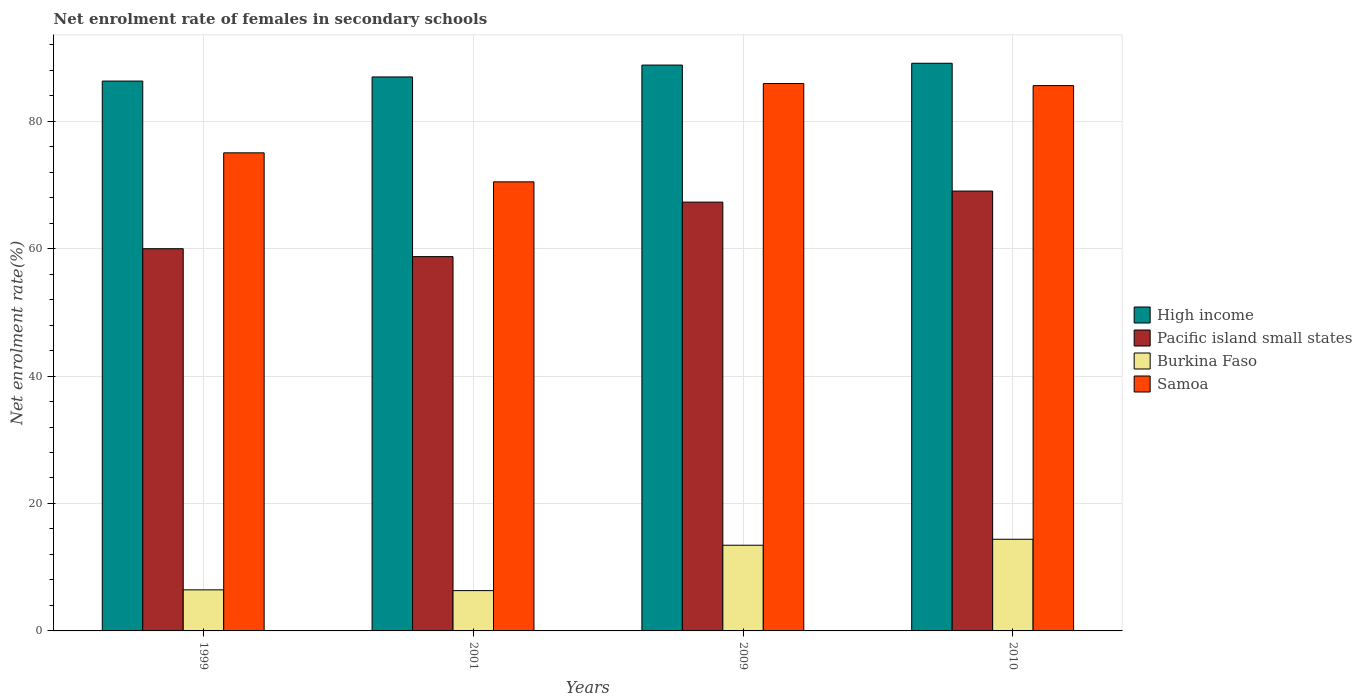How many bars are there on the 4th tick from the left?
Your answer should be compact. 4. How many bars are there on the 4th tick from the right?
Your answer should be very brief. 4. What is the label of the 3rd group of bars from the left?
Make the answer very short. 2009. What is the net enrolment rate of females in secondary schools in Samoa in 1999?
Keep it short and to the point. 75.03. Across all years, what is the maximum net enrolment rate of females in secondary schools in Samoa?
Keep it short and to the point. 85.9. Across all years, what is the minimum net enrolment rate of females in secondary schools in Burkina Faso?
Your answer should be very brief. 6.33. What is the total net enrolment rate of females in secondary schools in Samoa in the graph?
Your answer should be very brief. 316.98. What is the difference between the net enrolment rate of females in secondary schools in Burkina Faso in 1999 and that in 2010?
Offer a terse response. -7.94. What is the difference between the net enrolment rate of females in secondary schools in Samoa in 2010 and the net enrolment rate of females in secondary schools in Burkina Faso in 1999?
Your answer should be compact. 79.13. What is the average net enrolment rate of females in secondary schools in Pacific island small states per year?
Your answer should be compact. 63.76. In the year 2001, what is the difference between the net enrolment rate of females in secondary schools in Pacific island small states and net enrolment rate of females in secondary schools in High income?
Your response must be concise. -28.2. In how many years, is the net enrolment rate of females in secondary schools in Samoa greater than 72 %?
Give a very brief answer. 3. What is the ratio of the net enrolment rate of females in secondary schools in Pacific island small states in 2001 to that in 2009?
Provide a succinct answer. 0.87. Is the difference between the net enrolment rate of females in secondary schools in Pacific island small states in 1999 and 2009 greater than the difference between the net enrolment rate of females in secondary schools in High income in 1999 and 2009?
Offer a terse response. No. What is the difference between the highest and the second highest net enrolment rate of females in secondary schools in High income?
Make the answer very short. 0.28. What is the difference between the highest and the lowest net enrolment rate of females in secondary schools in High income?
Make the answer very short. 2.79. What does the 2nd bar from the right in 2001 represents?
Offer a terse response. Burkina Faso. Is it the case that in every year, the sum of the net enrolment rate of females in secondary schools in High income and net enrolment rate of females in secondary schools in Burkina Faso is greater than the net enrolment rate of females in secondary schools in Samoa?
Offer a very short reply. Yes. How many years are there in the graph?
Keep it short and to the point. 4. What is the difference between two consecutive major ticks on the Y-axis?
Give a very brief answer. 20. Are the values on the major ticks of Y-axis written in scientific E-notation?
Ensure brevity in your answer.  No. Does the graph contain grids?
Make the answer very short. Yes. Where does the legend appear in the graph?
Your answer should be very brief. Center right. How many legend labels are there?
Make the answer very short. 4. How are the legend labels stacked?
Ensure brevity in your answer.  Vertical. What is the title of the graph?
Give a very brief answer. Net enrolment rate of females in secondary schools. Does "Italy" appear as one of the legend labels in the graph?
Ensure brevity in your answer.  No. What is the label or title of the Y-axis?
Keep it short and to the point. Net enrolment rate(%). What is the Net enrolment rate(%) of High income in 1999?
Your answer should be very brief. 86.29. What is the Net enrolment rate(%) in Pacific island small states in 1999?
Provide a short and direct response. 59.98. What is the Net enrolment rate(%) of Burkina Faso in 1999?
Offer a terse response. 6.44. What is the Net enrolment rate(%) in Samoa in 1999?
Offer a very short reply. 75.03. What is the Net enrolment rate(%) in High income in 2001?
Your answer should be compact. 86.94. What is the Net enrolment rate(%) in Pacific island small states in 2001?
Keep it short and to the point. 58.74. What is the Net enrolment rate(%) of Burkina Faso in 2001?
Your response must be concise. 6.33. What is the Net enrolment rate(%) of Samoa in 2001?
Keep it short and to the point. 70.47. What is the Net enrolment rate(%) in High income in 2009?
Ensure brevity in your answer.  88.8. What is the Net enrolment rate(%) in Pacific island small states in 2009?
Your response must be concise. 67.29. What is the Net enrolment rate(%) in Burkina Faso in 2009?
Give a very brief answer. 13.45. What is the Net enrolment rate(%) of Samoa in 2009?
Your response must be concise. 85.9. What is the Net enrolment rate(%) of High income in 2010?
Your response must be concise. 89.08. What is the Net enrolment rate(%) in Pacific island small states in 2010?
Provide a short and direct response. 69.03. What is the Net enrolment rate(%) of Burkina Faso in 2010?
Offer a very short reply. 14.39. What is the Net enrolment rate(%) of Samoa in 2010?
Provide a short and direct response. 85.58. Across all years, what is the maximum Net enrolment rate(%) of High income?
Your answer should be very brief. 89.08. Across all years, what is the maximum Net enrolment rate(%) of Pacific island small states?
Make the answer very short. 69.03. Across all years, what is the maximum Net enrolment rate(%) of Burkina Faso?
Keep it short and to the point. 14.39. Across all years, what is the maximum Net enrolment rate(%) of Samoa?
Offer a very short reply. 85.9. Across all years, what is the minimum Net enrolment rate(%) in High income?
Offer a terse response. 86.29. Across all years, what is the minimum Net enrolment rate(%) of Pacific island small states?
Provide a short and direct response. 58.74. Across all years, what is the minimum Net enrolment rate(%) of Burkina Faso?
Offer a terse response. 6.33. Across all years, what is the minimum Net enrolment rate(%) of Samoa?
Offer a terse response. 70.47. What is the total Net enrolment rate(%) of High income in the graph?
Provide a succinct answer. 351.11. What is the total Net enrolment rate(%) in Pacific island small states in the graph?
Offer a very short reply. 255.04. What is the total Net enrolment rate(%) of Burkina Faso in the graph?
Make the answer very short. 40.6. What is the total Net enrolment rate(%) in Samoa in the graph?
Offer a terse response. 316.98. What is the difference between the Net enrolment rate(%) in High income in 1999 and that in 2001?
Give a very brief answer. -0.65. What is the difference between the Net enrolment rate(%) in Pacific island small states in 1999 and that in 2001?
Keep it short and to the point. 1.24. What is the difference between the Net enrolment rate(%) in Burkina Faso in 1999 and that in 2001?
Provide a short and direct response. 0.12. What is the difference between the Net enrolment rate(%) of Samoa in 1999 and that in 2001?
Your answer should be compact. 4.55. What is the difference between the Net enrolment rate(%) in High income in 1999 and that in 2009?
Your answer should be compact. -2.51. What is the difference between the Net enrolment rate(%) of Pacific island small states in 1999 and that in 2009?
Your answer should be very brief. -7.31. What is the difference between the Net enrolment rate(%) in Burkina Faso in 1999 and that in 2009?
Your answer should be very brief. -7. What is the difference between the Net enrolment rate(%) in Samoa in 1999 and that in 2009?
Your answer should be compact. -10.88. What is the difference between the Net enrolment rate(%) in High income in 1999 and that in 2010?
Your answer should be very brief. -2.79. What is the difference between the Net enrolment rate(%) of Pacific island small states in 1999 and that in 2010?
Offer a very short reply. -9.05. What is the difference between the Net enrolment rate(%) in Burkina Faso in 1999 and that in 2010?
Your answer should be compact. -7.94. What is the difference between the Net enrolment rate(%) of Samoa in 1999 and that in 2010?
Make the answer very short. -10.55. What is the difference between the Net enrolment rate(%) of High income in 2001 and that in 2009?
Your answer should be compact. -1.86. What is the difference between the Net enrolment rate(%) in Pacific island small states in 2001 and that in 2009?
Offer a very short reply. -8.55. What is the difference between the Net enrolment rate(%) in Burkina Faso in 2001 and that in 2009?
Your answer should be compact. -7.12. What is the difference between the Net enrolment rate(%) in Samoa in 2001 and that in 2009?
Your answer should be compact. -15.43. What is the difference between the Net enrolment rate(%) of High income in 2001 and that in 2010?
Provide a short and direct response. -2.15. What is the difference between the Net enrolment rate(%) in Pacific island small states in 2001 and that in 2010?
Provide a succinct answer. -10.29. What is the difference between the Net enrolment rate(%) of Burkina Faso in 2001 and that in 2010?
Provide a short and direct response. -8.06. What is the difference between the Net enrolment rate(%) of Samoa in 2001 and that in 2010?
Make the answer very short. -15.1. What is the difference between the Net enrolment rate(%) of High income in 2009 and that in 2010?
Offer a terse response. -0.28. What is the difference between the Net enrolment rate(%) of Pacific island small states in 2009 and that in 2010?
Your response must be concise. -1.73. What is the difference between the Net enrolment rate(%) in Burkina Faso in 2009 and that in 2010?
Offer a terse response. -0.94. What is the difference between the Net enrolment rate(%) of Samoa in 2009 and that in 2010?
Your answer should be compact. 0.32. What is the difference between the Net enrolment rate(%) of High income in 1999 and the Net enrolment rate(%) of Pacific island small states in 2001?
Offer a terse response. 27.55. What is the difference between the Net enrolment rate(%) of High income in 1999 and the Net enrolment rate(%) of Burkina Faso in 2001?
Make the answer very short. 79.96. What is the difference between the Net enrolment rate(%) of High income in 1999 and the Net enrolment rate(%) of Samoa in 2001?
Keep it short and to the point. 15.82. What is the difference between the Net enrolment rate(%) of Pacific island small states in 1999 and the Net enrolment rate(%) of Burkina Faso in 2001?
Offer a very short reply. 53.66. What is the difference between the Net enrolment rate(%) in Pacific island small states in 1999 and the Net enrolment rate(%) in Samoa in 2001?
Keep it short and to the point. -10.49. What is the difference between the Net enrolment rate(%) in Burkina Faso in 1999 and the Net enrolment rate(%) in Samoa in 2001?
Offer a terse response. -64.03. What is the difference between the Net enrolment rate(%) in High income in 1999 and the Net enrolment rate(%) in Pacific island small states in 2009?
Your answer should be very brief. 19. What is the difference between the Net enrolment rate(%) of High income in 1999 and the Net enrolment rate(%) of Burkina Faso in 2009?
Your response must be concise. 72.84. What is the difference between the Net enrolment rate(%) in High income in 1999 and the Net enrolment rate(%) in Samoa in 2009?
Give a very brief answer. 0.39. What is the difference between the Net enrolment rate(%) of Pacific island small states in 1999 and the Net enrolment rate(%) of Burkina Faso in 2009?
Your answer should be compact. 46.53. What is the difference between the Net enrolment rate(%) of Pacific island small states in 1999 and the Net enrolment rate(%) of Samoa in 2009?
Keep it short and to the point. -25.92. What is the difference between the Net enrolment rate(%) in Burkina Faso in 1999 and the Net enrolment rate(%) in Samoa in 2009?
Provide a short and direct response. -79.46. What is the difference between the Net enrolment rate(%) in High income in 1999 and the Net enrolment rate(%) in Pacific island small states in 2010?
Give a very brief answer. 17.26. What is the difference between the Net enrolment rate(%) in High income in 1999 and the Net enrolment rate(%) in Burkina Faso in 2010?
Ensure brevity in your answer.  71.9. What is the difference between the Net enrolment rate(%) of High income in 1999 and the Net enrolment rate(%) of Samoa in 2010?
Offer a terse response. 0.71. What is the difference between the Net enrolment rate(%) of Pacific island small states in 1999 and the Net enrolment rate(%) of Burkina Faso in 2010?
Your response must be concise. 45.6. What is the difference between the Net enrolment rate(%) in Pacific island small states in 1999 and the Net enrolment rate(%) in Samoa in 2010?
Keep it short and to the point. -25.6. What is the difference between the Net enrolment rate(%) in Burkina Faso in 1999 and the Net enrolment rate(%) in Samoa in 2010?
Give a very brief answer. -79.13. What is the difference between the Net enrolment rate(%) of High income in 2001 and the Net enrolment rate(%) of Pacific island small states in 2009?
Make the answer very short. 19.64. What is the difference between the Net enrolment rate(%) of High income in 2001 and the Net enrolment rate(%) of Burkina Faso in 2009?
Your answer should be very brief. 73.49. What is the difference between the Net enrolment rate(%) in High income in 2001 and the Net enrolment rate(%) in Samoa in 2009?
Provide a succinct answer. 1.03. What is the difference between the Net enrolment rate(%) of Pacific island small states in 2001 and the Net enrolment rate(%) of Burkina Faso in 2009?
Offer a terse response. 45.29. What is the difference between the Net enrolment rate(%) in Pacific island small states in 2001 and the Net enrolment rate(%) in Samoa in 2009?
Provide a succinct answer. -27.16. What is the difference between the Net enrolment rate(%) of Burkina Faso in 2001 and the Net enrolment rate(%) of Samoa in 2009?
Your response must be concise. -79.58. What is the difference between the Net enrolment rate(%) of High income in 2001 and the Net enrolment rate(%) of Pacific island small states in 2010?
Provide a succinct answer. 17.91. What is the difference between the Net enrolment rate(%) of High income in 2001 and the Net enrolment rate(%) of Burkina Faso in 2010?
Offer a very short reply. 72.55. What is the difference between the Net enrolment rate(%) of High income in 2001 and the Net enrolment rate(%) of Samoa in 2010?
Provide a short and direct response. 1.36. What is the difference between the Net enrolment rate(%) of Pacific island small states in 2001 and the Net enrolment rate(%) of Burkina Faso in 2010?
Provide a succinct answer. 44.36. What is the difference between the Net enrolment rate(%) in Pacific island small states in 2001 and the Net enrolment rate(%) in Samoa in 2010?
Make the answer very short. -26.84. What is the difference between the Net enrolment rate(%) of Burkina Faso in 2001 and the Net enrolment rate(%) of Samoa in 2010?
Keep it short and to the point. -79.25. What is the difference between the Net enrolment rate(%) of High income in 2009 and the Net enrolment rate(%) of Pacific island small states in 2010?
Ensure brevity in your answer.  19.77. What is the difference between the Net enrolment rate(%) of High income in 2009 and the Net enrolment rate(%) of Burkina Faso in 2010?
Keep it short and to the point. 74.41. What is the difference between the Net enrolment rate(%) in High income in 2009 and the Net enrolment rate(%) in Samoa in 2010?
Provide a succinct answer. 3.22. What is the difference between the Net enrolment rate(%) of Pacific island small states in 2009 and the Net enrolment rate(%) of Burkina Faso in 2010?
Your answer should be compact. 52.91. What is the difference between the Net enrolment rate(%) in Pacific island small states in 2009 and the Net enrolment rate(%) in Samoa in 2010?
Make the answer very short. -18.28. What is the difference between the Net enrolment rate(%) in Burkina Faso in 2009 and the Net enrolment rate(%) in Samoa in 2010?
Offer a very short reply. -72.13. What is the average Net enrolment rate(%) in High income per year?
Provide a short and direct response. 87.78. What is the average Net enrolment rate(%) in Pacific island small states per year?
Provide a short and direct response. 63.76. What is the average Net enrolment rate(%) in Burkina Faso per year?
Provide a succinct answer. 10.15. What is the average Net enrolment rate(%) in Samoa per year?
Offer a very short reply. 79.25. In the year 1999, what is the difference between the Net enrolment rate(%) in High income and Net enrolment rate(%) in Pacific island small states?
Keep it short and to the point. 26.31. In the year 1999, what is the difference between the Net enrolment rate(%) in High income and Net enrolment rate(%) in Burkina Faso?
Give a very brief answer. 79.84. In the year 1999, what is the difference between the Net enrolment rate(%) in High income and Net enrolment rate(%) in Samoa?
Give a very brief answer. 11.26. In the year 1999, what is the difference between the Net enrolment rate(%) in Pacific island small states and Net enrolment rate(%) in Burkina Faso?
Provide a succinct answer. 53.54. In the year 1999, what is the difference between the Net enrolment rate(%) of Pacific island small states and Net enrolment rate(%) of Samoa?
Make the answer very short. -15.05. In the year 1999, what is the difference between the Net enrolment rate(%) of Burkina Faso and Net enrolment rate(%) of Samoa?
Your response must be concise. -68.58. In the year 2001, what is the difference between the Net enrolment rate(%) of High income and Net enrolment rate(%) of Pacific island small states?
Make the answer very short. 28.2. In the year 2001, what is the difference between the Net enrolment rate(%) of High income and Net enrolment rate(%) of Burkina Faso?
Make the answer very short. 80.61. In the year 2001, what is the difference between the Net enrolment rate(%) in High income and Net enrolment rate(%) in Samoa?
Offer a terse response. 16.46. In the year 2001, what is the difference between the Net enrolment rate(%) in Pacific island small states and Net enrolment rate(%) in Burkina Faso?
Give a very brief answer. 52.41. In the year 2001, what is the difference between the Net enrolment rate(%) of Pacific island small states and Net enrolment rate(%) of Samoa?
Your answer should be very brief. -11.73. In the year 2001, what is the difference between the Net enrolment rate(%) in Burkina Faso and Net enrolment rate(%) in Samoa?
Offer a terse response. -64.15. In the year 2009, what is the difference between the Net enrolment rate(%) in High income and Net enrolment rate(%) in Pacific island small states?
Offer a very short reply. 21.51. In the year 2009, what is the difference between the Net enrolment rate(%) in High income and Net enrolment rate(%) in Burkina Faso?
Provide a short and direct response. 75.35. In the year 2009, what is the difference between the Net enrolment rate(%) in High income and Net enrolment rate(%) in Samoa?
Make the answer very short. 2.9. In the year 2009, what is the difference between the Net enrolment rate(%) in Pacific island small states and Net enrolment rate(%) in Burkina Faso?
Your response must be concise. 53.85. In the year 2009, what is the difference between the Net enrolment rate(%) in Pacific island small states and Net enrolment rate(%) in Samoa?
Ensure brevity in your answer.  -18.61. In the year 2009, what is the difference between the Net enrolment rate(%) of Burkina Faso and Net enrolment rate(%) of Samoa?
Offer a very short reply. -72.45. In the year 2010, what is the difference between the Net enrolment rate(%) of High income and Net enrolment rate(%) of Pacific island small states?
Keep it short and to the point. 20.06. In the year 2010, what is the difference between the Net enrolment rate(%) in High income and Net enrolment rate(%) in Burkina Faso?
Ensure brevity in your answer.  74.7. In the year 2010, what is the difference between the Net enrolment rate(%) in High income and Net enrolment rate(%) in Samoa?
Your response must be concise. 3.51. In the year 2010, what is the difference between the Net enrolment rate(%) of Pacific island small states and Net enrolment rate(%) of Burkina Faso?
Make the answer very short. 54.64. In the year 2010, what is the difference between the Net enrolment rate(%) of Pacific island small states and Net enrolment rate(%) of Samoa?
Offer a very short reply. -16.55. In the year 2010, what is the difference between the Net enrolment rate(%) in Burkina Faso and Net enrolment rate(%) in Samoa?
Ensure brevity in your answer.  -71.19. What is the ratio of the Net enrolment rate(%) of Pacific island small states in 1999 to that in 2001?
Give a very brief answer. 1.02. What is the ratio of the Net enrolment rate(%) of Burkina Faso in 1999 to that in 2001?
Your answer should be very brief. 1.02. What is the ratio of the Net enrolment rate(%) in Samoa in 1999 to that in 2001?
Keep it short and to the point. 1.06. What is the ratio of the Net enrolment rate(%) of High income in 1999 to that in 2009?
Your response must be concise. 0.97. What is the ratio of the Net enrolment rate(%) in Pacific island small states in 1999 to that in 2009?
Offer a very short reply. 0.89. What is the ratio of the Net enrolment rate(%) of Burkina Faso in 1999 to that in 2009?
Your answer should be very brief. 0.48. What is the ratio of the Net enrolment rate(%) in Samoa in 1999 to that in 2009?
Ensure brevity in your answer.  0.87. What is the ratio of the Net enrolment rate(%) in High income in 1999 to that in 2010?
Your response must be concise. 0.97. What is the ratio of the Net enrolment rate(%) of Pacific island small states in 1999 to that in 2010?
Ensure brevity in your answer.  0.87. What is the ratio of the Net enrolment rate(%) in Burkina Faso in 1999 to that in 2010?
Provide a short and direct response. 0.45. What is the ratio of the Net enrolment rate(%) in Samoa in 1999 to that in 2010?
Offer a very short reply. 0.88. What is the ratio of the Net enrolment rate(%) of Pacific island small states in 2001 to that in 2009?
Keep it short and to the point. 0.87. What is the ratio of the Net enrolment rate(%) in Burkina Faso in 2001 to that in 2009?
Ensure brevity in your answer.  0.47. What is the ratio of the Net enrolment rate(%) in Samoa in 2001 to that in 2009?
Make the answer very short. 0.82. What is the ratio of the Net enrolment rate(%) of High income in 2001 to that in 2010?
Provide a succinct answer. 0.98. What is the ratio of the Net enrolment rate(%) in Pacific island small states in 2001 to that in 2010?
Provide a succinct answer. 0.85. What is the ratio of the Net enrolment rate(%) in Burkina Faso in 2001 to that in 2010?
Your answer should be compact. 0.44. What is the ratio of the Net enrolment rate(%) of Samoa in 2001 to that in 2010?
Give a very brief answer. 0.82. What is the ratio of the Net enrolment rate(%) of Pacific island small states in 2009 to that in 2010?
Keep it short and to the point. 0.97. What is the ratio of the Net enrolment rate(%) of Burkina Faso in 2009 to that in 2010?
Provide a short and direct response. 0.93. What is the difference between the highest and the second highest Net enrolment rate(%) in High income?
Make the answer very short. 0.28. What is the difference between the highest and the second highest Net enrolment rate(%) of Pacific island small states?
Provide a succinct answer. 1.73. What is the difference between the highest and the second highest Net enrolment rate(%) in Burkina Faso?
Provide a short and direct response. 0.94. What is the difference between the highest and the second highest Net enrolment rate(%) of Samoa?
Provide a short and direct response. 0.32. What is the difference between the highest and the lowest Net enrolment rate(%) in High income?
Give a very brief answer. 2.79. What is the difference between the highest and the lowest Net enrolment rate(%) of Pacific island small states?
Keep it short and to the point. 10.29. What is the difference between the highest and the lowest Net enrolment rate(%) in Burkina Faso?
Make the answer very short. 8.06. What is the difference between the highest and the lowest Net enrolment rate(%) in Samoa?
Give a very brief answer. 15.43. 